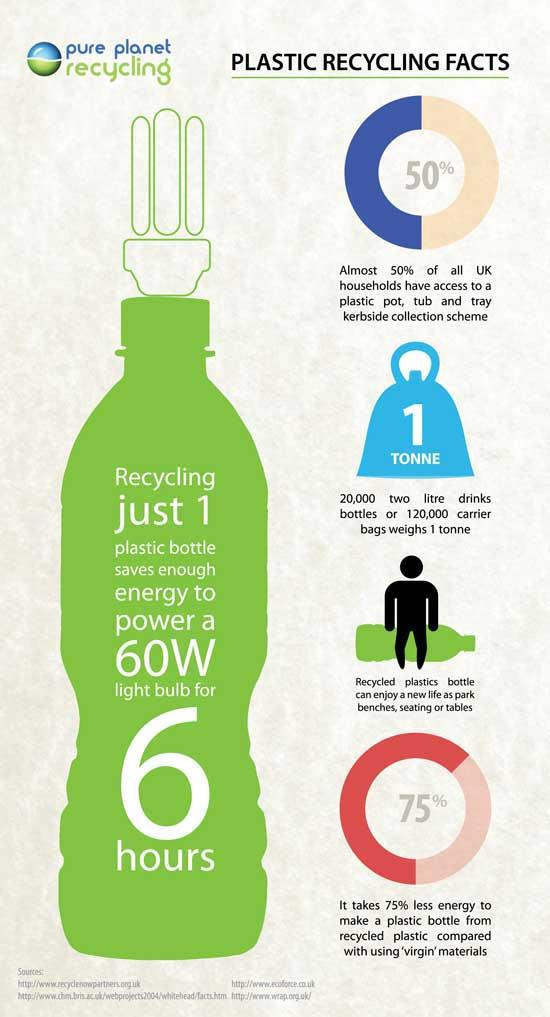Mention a couple of crucial points in this snapshot. According to recent statistics, approximately 50% of all UK households do not have access to a plastic pot, tub, and tray kerbside collection scheme. 